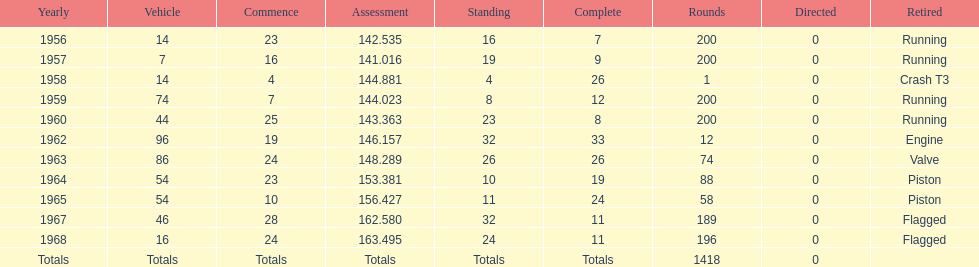Can you parse all the data within this table? {'header': ['Yearly', 'Vehicle', 'Commence', 'Assessment', 'Standing', 'Complete', 'Rounds', 'Directed', 'Retired'], 'rows': [['1956', '14', '23', '142.535', '16', '7', '200', '0', 'Running'], ['1957', '7', '16', '141.016', '19', '9', '200', '0', 'Running'], ['1958', '14', '4', '144.881', '4', '26', '1', '0', 'Crash T3'], ['1959', '74', '7', '144.023', '8', '12', '200', '0', 'Running'], ['1960', '44', '25', '143.363', '23', '8', '200', '0', 'Running'], ['1962', '96', '19', '146.157', '32', '33', '12', '0', 'Engine'], ['1963', '86', '24', '148.289', '26', '26', '74', '0', 'Valve'], ['1964', '54', '23', '153.381', '10', '19', '88', '0', 'Piston'], ['1965', '54', '10', '156.427', '11', '24', '58', '0', 'Piston'], ['1967', '46', '28', '162.580', '32', '11', '189', '0', 'Flagged'], ['1968', '16', '24', '163.495', '24', '11', '196', '0', 'Flagged'], ['Totals', 'Totals', 'Totals', 'Totals', 'Totals', 'Totals', '1418', '0', '']]} What year did he have the same number car as 1964? 1965. 